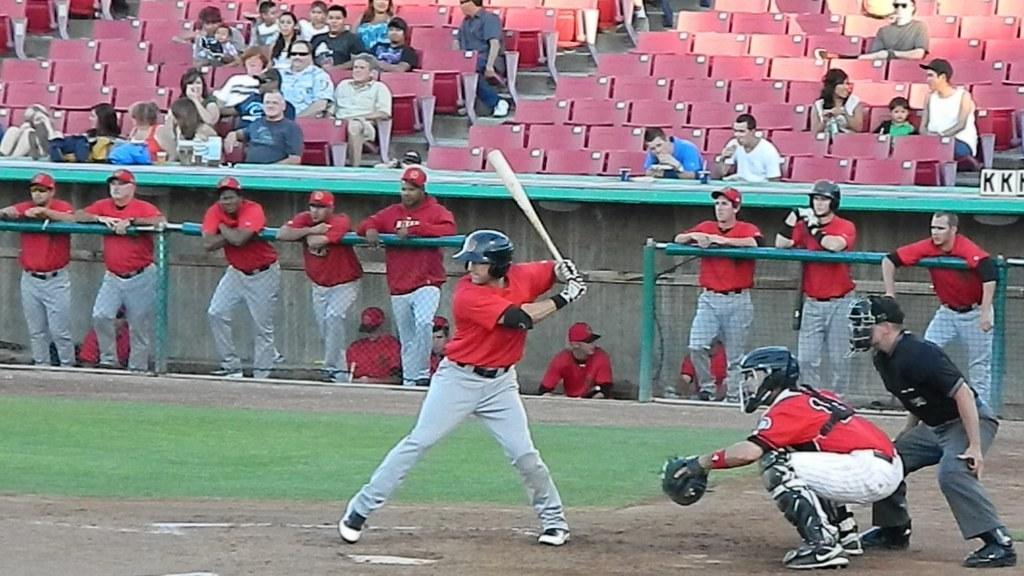<image>
Relay a brief, clear account of the picture shown. a catcher that has the number 1 on the back of his jersey 